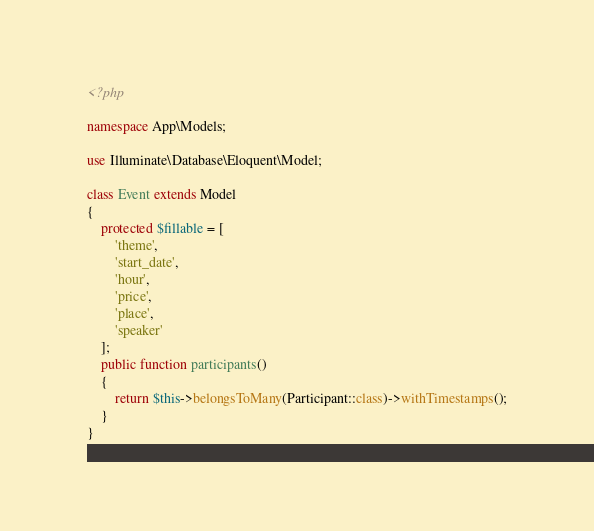Convert code to text. <code><loc_0><loc_0><loc_500><loc_500><_PHP_><?php

namespace App\Models;

use Illuminate\Database\Eloquent\Model;

class Event extends Model
{
    protected $fillable = [
        'theme',
        'start_date',
        'hour',
        'price',
        'place',
        'speaker'
    ];
    public function participants()
    {
        return $this->belongsToMany(Participant::class)->withTimestamps();
    }
}
</code> 